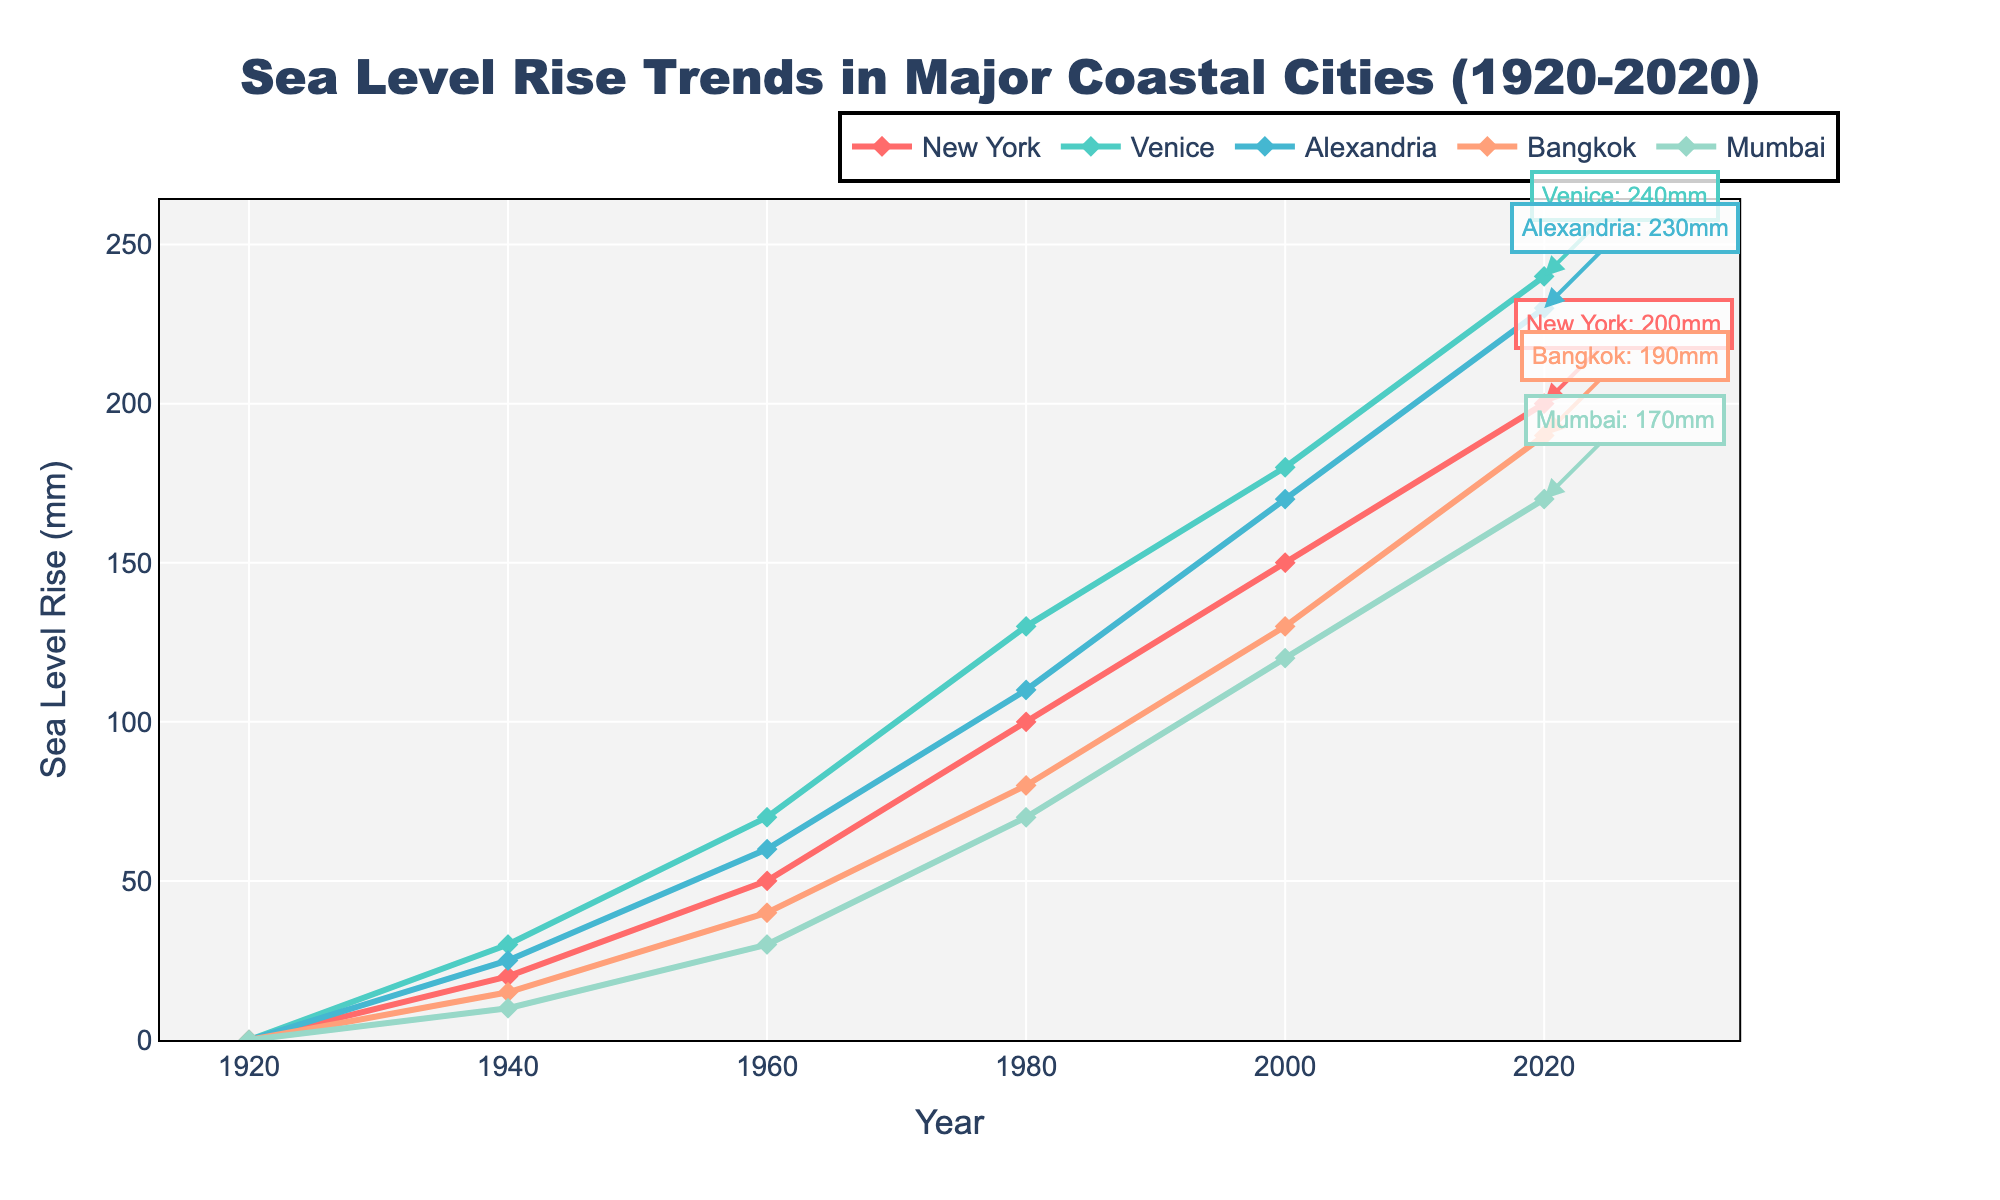What is the total sea level rise in New York between 1920 and 2020? To find the total sea level rise in New York between 1920 and 2020, subtract the sea level rise in 1920 from the sea level rise in 2020. This is 200 mm (2020) - 0 mm (1920) = 200 mm.
Answer: 200 mm Which city experienced the highest sea level rise by 2020, and how much was it? By comparing the annotations next to each city in 2020, Venice experienced the highest sea level rise, with an increase of 240 mm.
Answer: Venice, 240 mm How much more sea level rise did Bangkok experience compared to Mumbai in 2020? To find out the difference in sea level rise between Bangkok and Mumbai in 2020, subtract Mumbai's rise from Bangkok's rise. This is 190 mm (Bangkok) - 170 mm (Mumbai) = 20 mm.
Answer: 20 mm Between which years did New York experience the greatest increase in sea level, and what was the increase? To determine when New York saw the greatest increase, look at the differences between the given points: 
- 1940 to 1960: 50 mm - 20 mm = 30 mm
- 1960 to 1980: 100 mm - 50 mm = 50 mm
- 1980 to 2000: 150 mm - 100 mm = 50 mm
- 2000 to 2020: 200 mm - 150 mm = 50 mm
The changes are equal between 1960-1980, 1980-2000, and 2000-2020, each having a 50 mm increase.
Answer: 1960 to 1980, 50 mm (also same for 1980 to 2000 and 2000 to 2020) Which city had the lowest sea level rise in 1960, and what was it? By looking at the values in the 1960 column for each city, Mumbai had the lowest sea level rise at 30 mm.
Answer: Mumbai, 30 mm Calculate the average sea level rise across all cities in 2020. Add the sea level rises for all cities in 2020 and divide by the number of cities. (200 mm (New York) + 240 mm (Venice) + 230 mm (Alexandria) + 190 mm (Bangkok) + 170 mm (Mumbai)) / 5 = 1030 mm / 5 = 206 mm.
Answer: 206 mm Which color represents Bangkok in the chart? The color representing Bangkok can be identified by looking at the chart legend or the line color for Bangkok. Bangkok is represented by a light salmon color.
Answer: Light salmon What trend can be observed for Alexandria from 1920 to 2020? By analyzing the slope of Alexandria's line in the chart, we observe a steady and continuous increase in sea level rise, reaching 230 mm by 2020.
Answer: Steady increase What is the combined sea level rise for Venice and Alexandria in the year 2000? Sum the sea level rise values for Venice and Alexandria in 2000. This is 180 mm (Venice) + 170 mm (Alexandria) = 350 mm.
Answer: 350 mm 